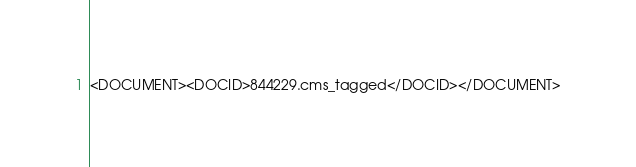<code> <loc_0><loc_0><loc_500><loc_500><_XML_><DOCUMENT><DOCID>844229.cms_tagged</DOCID></DOCUMENT></code> 